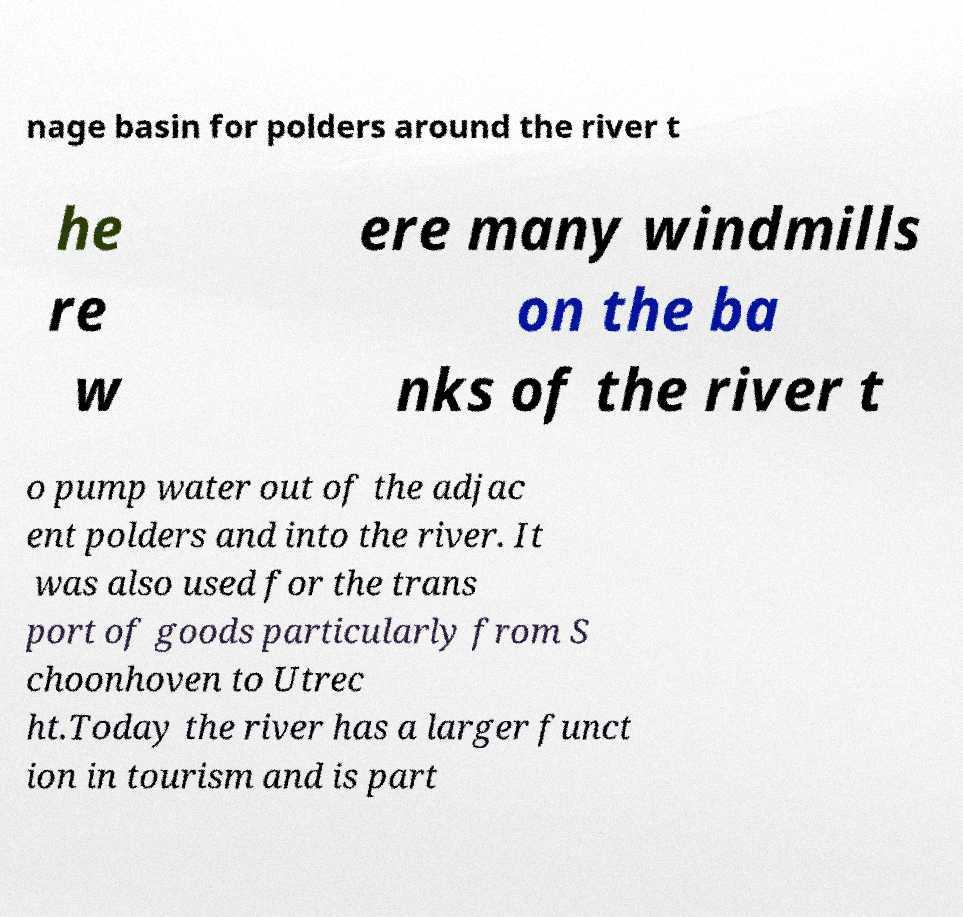What messages or text are displayed in this image? I need them in a readable, typed format. nage basin for polders around the river t he re w ere many windmills on the ba nks of the river t o pump water out of the adjac ent polders and into the river. It was also used for the trans port of goods particularly from S choonhoven to Utrec ht.Today the river has a larger funct ion in tourism and is part 